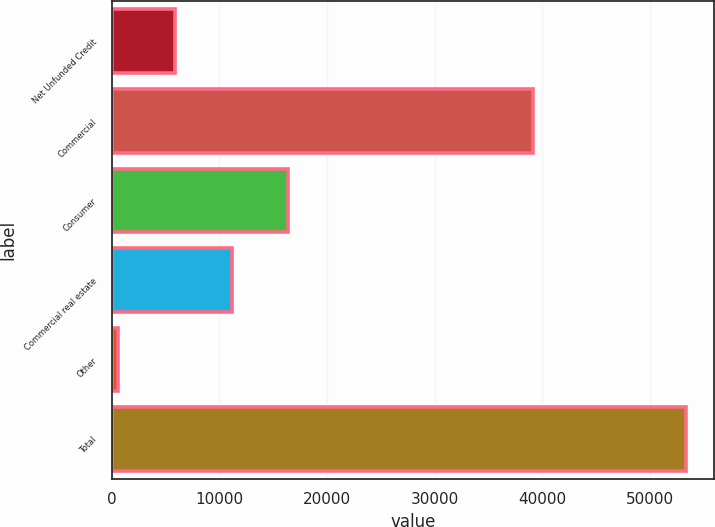Convert chart to OTSL. <chart><loc_0><loc_0><loc_500><loc_500><bar_chart><fcel>Net Unfunded Credit<fcel>Commercial<fcel>Consumer<fcel>Commercial real estate<fcel>Other<fcel>Total<nl><fcel>5845<fcel>39171<fcel>16401<fcel>11123<fcel>567<fcel>53347<nl></chart> 